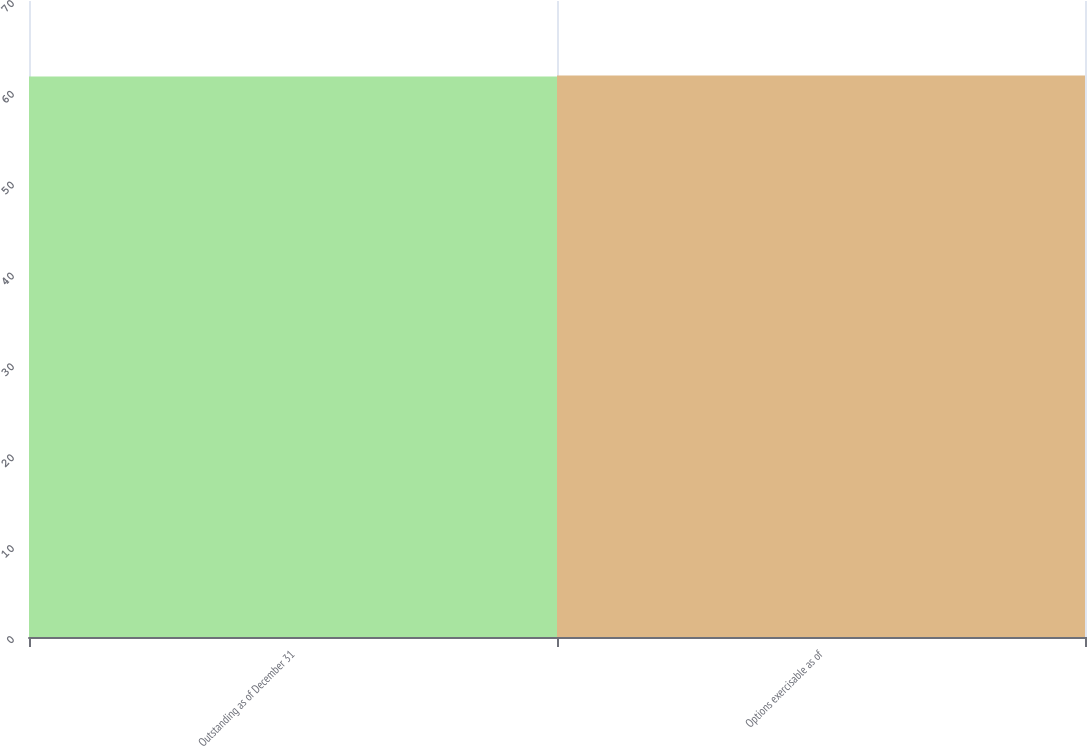<chart> <loc_0><loc_0><loc_500><loc_500><bar_chart><fcel>Outstanding as of December 31<fcel>Options exercisable as of<nl><fcel>61.7<fcel>61.8<nl></chart> 